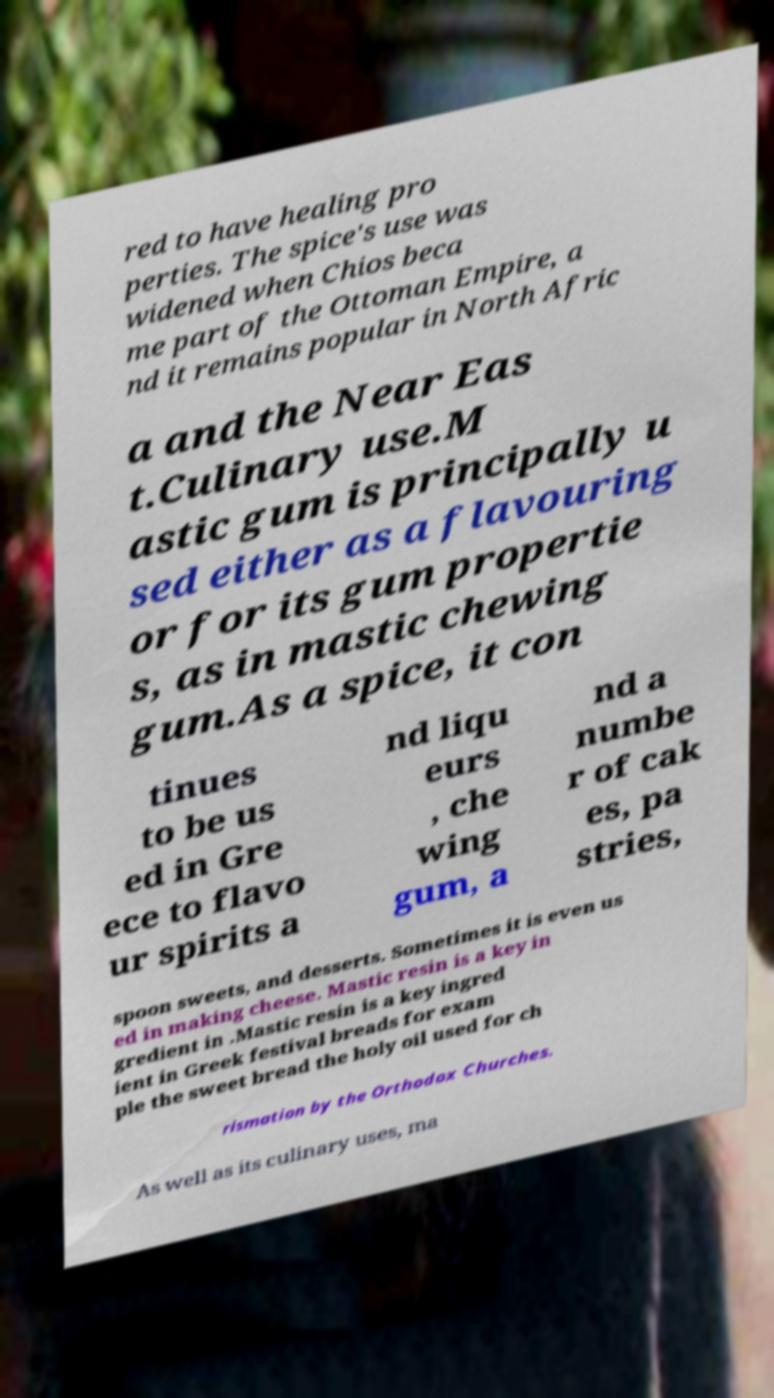For documentation purposes, I need the text within this image transcribed. Could you provide that? red to have healing pro perties. The spice's use was widened when Chios beca me part of the Ottoman Empire, a nd it remains popular in North Afric a and the Near Eas t.Culinary use.M astic gum is principally u sed either as a flavouring or for its gum propertie s, as in mastic chewing gum.As a spice, it con tinues to be us ed in Gre ece to flavo ur spirits a nd liqu eurs , che wing gum, a nd a numbe r of cak es, pa stries, spoon sweets, and desserts. Sometimes it is even us ed in making cheese. Mastic resin is a key in gredient in .Mastic resin is a key ingred ient in Greek festival breads for exam ple the sweet bread the holy oil used for ch rismation by the Orthodox Churches. As well as its culinary uses, ma 